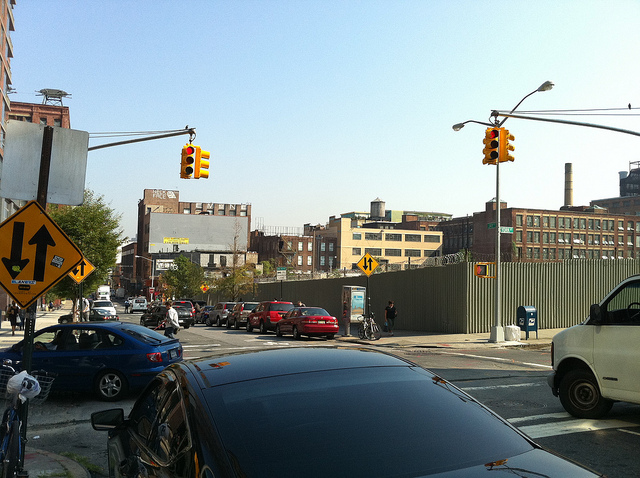<image>What city is this? It is ambiguous to determine the city. However, it may be New York. What city is this? I am not sure what city this is. It can be Charlottesville VA, LA, Queens, Atlanta, New York, or Detroit. There is not enough information to determine the exact city. 